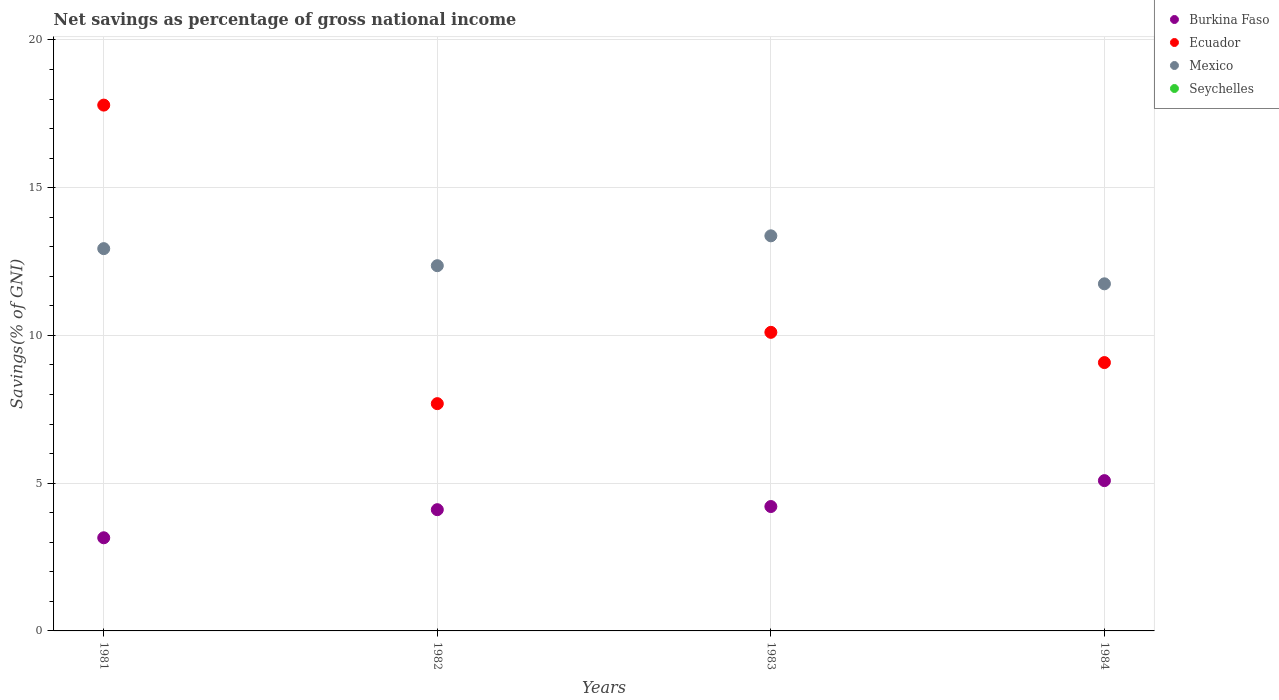What is the total savings in Mexico in 1983?
Provide a succinct answer. 13.37. Across all years, what is the maximum total savings in Mexico?
Provide a succinct answer. 13.37. Across all years, what is the minimum total savings in Ecuador?
Make the answer very short. 7.69. What is the total total savings in Seychelles in the graph?
Provide a succinct answer. 0. What is the difference between the total savings in Mexico in 1983 and that in 1984?
Make the answer very short. 1.62. What is the difference between the total savings in Mexico in 1981 and the total savings in Burkina Faso in 1982?
Your answer should be compact. 8.83. In the year 1981, what is the difference between the total savings in Ecuador and total savings in Burkina Faso?
Your answer should be compact. 14.64. In how many years, is the total savings in Mexico greater than 3 %?
Ensure brevity in your answer.  4. What is the ratio of the total savings in Burkina Faso in 1981 to that in 1983?
Provide a succinct answer. 0.75. What is the difference between the highest and the second highest total savings in Burkina Faso?
Provide a short and direct response. 0.88. What is the difference between the highest and the lowest total savings in Ecuador?
Ensure brevity in your answer.  10.1. Does the total savings in Mexico monotonically increase over the years?
Your response must be concise. No. Is the total savings in Burkina Faso strictly greater than the total savings in Ecuador over the years?
Give a very brief answer. No. Is the total savings in Ecuador strictly less than the total savings in Seychelles over the years?
Offer a terse response. No. How many dotlines are there?
Give a very brief answer. 3. How many years are there in the graph?
Provide a succinct answer. 4. What is the difference between two consecutive major ticks on the Y-axis?
Provide a succinct answer. 5. Are the values on the major ticks of Y-axis written in scientific E-notation?
Your answer should be compact. No. Does the graph contain any zero values?
Ensure brevity in your answer.  Yes. Does the graph contain grids?
Offer a very short reply. Yes. Where does the legend appear in the graph?
Keep it short and to the point. Top right. How many legend labels are there?
Ensure brevity in your answer.  4. How are the legend labels stacked?
Provide a succinct answer. Vertical. What is the title of the graph?
Keep it short and to the point. Net savings as percentage of gross national income. Does "Algeria" appear as one of the legend labels in the graph?
Offer a terse response. No. What is the label or title of the Y-axis?
Your answer should be very brief. Savings(% of GNI). What is the Savings(% of GNI) in Burkina Faso in 1981?
Your response must be concise. 3.15. What is the Savings(% of GNI) of Ecuador in 1981?
Offer a very short reply. 17.79. What is the Savings(% of GNI) in Mexico in 1981?
Your answer should be compact. 12.94. What is the Savings(% of GNI) in Seychelles in 1981?
Your response must be concise. 0. What is the Savings(% of GNI) in Burkina Faso in 1982?
Keep it short and to the point. 4.1. What is the Savings(% of GNI) in Ecuador in 1982?
Give a very brief answer. 7.69. What is the Savings(% of GNI) of Mexico in 1982?
Make the answer very short. 12.36. What is the Savings(% of GNI) of Burkina Faso in 1983?
Provide a short and direct response. 4.21. What is the Savings(% of GNI) in Ecuador in 1983?
Keep it short and to the point. 10.1. What is the Savings(% of GNI) in Mexico in 1983?
Give a very brief answer. 13.37. What is the Savings(% of GNI) in Burkina Faso in 1984?
Your answer should be compact. 5.09. What is the Savings(% of GNI) of Ecuador in 1984?
Your answer should be compact. 9.08. What is the Savings(% of GNI) in Mexico in 1984?
Ensure brevity in your answer.  11.75. What is the Savings(% of GNI) in Seychelles in 1984?
Ensure brevity in your answer.  0. Across all years, what is the maximum Savings(% of GNI) of Burkina Faso?
Provide a short and direct response. 5.09. Across all years, what is the maximum Savings(% of GNI) of Ecuador?
Make the answer very short. 17.79. Across all years, what is the maximum Savings(% of GNI) in Mexico?
Offer a terse response. 13.37. Across all years, what is the minimum Savings(% of GNI) of Burkina Faso?
Provide a short and direct response. 3.15. Across all years, what is the minimum Savings(% of GNI) of Ecuador?
Your answer should be compact. 7.69. Across all years, what is the minimum Savings(% of GNI) of Mexico?
Your answer should be compact. 11.75. What is the total Savings(% of GNI) of Burkina Faso in the graph?
Your response must be concise. 16.55. What is the total Savings(% of GNI) in Ecuador in the graph?
Give a very brief answer. 44.67. What is the total Savings(% of GNI) in Mexico in the graph?
Offer a very short reply. 50.41. What is the total Savings(% of GNI) in Seychelles in the graph?
Give a very brief answer. 0. What is the difference between the Savings(% of GNI) of Burkina Faso in 1981 and that in 1982?
Keep it short and to the point. -0.95. What is the difference between the Savings(% of GNI) of Ecuador in 1981 and that in 1982?
Your answer should be compact. 10.1. What is the difference between the Savings(% of GNI) in Mexico in 1981 and that in 1982?
Provide a short and direct response. 0.58. What is the difference between the Savings(% of GNI) of Burkina Faso in 1981 and that in 1983?
Offer a terse response. -1.06. What is the difference between the Savings(% of GNI) in Ecuador in 1981 and that in 1983?
Provide a succinct answer. 7.69. What is the difference between the Savings(% of GNI) of Mexico in 1981 and that in 1983?
Provide a succinct answer. -0.43. What is the difference between the Savings(% of GNI) of Burkina Faso in 1981 and that in 1984?
Your answer should be very brief. -1.93. What is the difference between the Savings(% of GNI) of Ecuador in 1981 and that in 1984?
Give a very brief answer. 8.71. What is the difference between the Savings(% of GNI) of Mexico in 1981 and that in 1984?
Give a very brief answer. 1.19. What is the difference between the Savings(% of GNI) in Burkina Faso in 1982 and that in 1983?
Make the answer very short. -0.11. What is the difference between the Savings(% of GNI) of Ecuador in 1982 and that in 1983?
Keep it short and to the point. -2.41. What is the difference between the Savings(% of GNI) in Mexico in 1982 and that in 1983?
Give a very brief answer. -1.01. What is the difference between the Savings(% of GNI) in Burkina Faso in 1982 and that in 1984?
Provide a succinct answer. -0.98. What is the difference between the Savings(% of GNI) of Ecuador in 1982 and that in 1984?
Give a very brief answer. -1.39. What is the difference between the Savings(% of GNI) of Mexico in 1982 and that in 1984?
Give a very brief answer. 0.61. What is the difference between the Savings(% of GNI) of Burkina Faso in 1983 and that in 1984?
Provide a succinct answer. -0.88. What is the difference between the Savings(% of GNI) in Ecuador in 1983 and that in 1984?
Your response must be concise. 1.02. What is the difference between the Savings(% of GNI) of Mexico in 1983 and that in 1984?
Offer a terse response. 1.62. What is the difference between the Savings(% of GNI) in Burkina Faso in 1981 and the Savings(% of GNI) in Ecuador in 1982?
Your response must be concise. -4.54. What is the difference between the Savings(% of GNI) of Burkina Faso in 1981 and the Savings(% of GNI) of Mexico in 1982?
Your answer should be very brief. -9.21. What is the difference between the Savings(% of GNI) of Ecuador in 1981 and the Savings(% of GNI) of Mexico in 1982?
Keep it short and to the point. 5.43. What is the difference between the Savings(% of GNI) of Burkina Faso in 1981 and the Savings(% of GNI) of Ecuador in 1983?
Provide a short and direct response. -6.95. What is the difference between the Savings(% of GNI) of Burkina Faso in 1981 and the Savings(% of GNI) of Mexico in 1983?
Make the answer very short. -10.22. What is the difference between the Savings(% of GNI) in Ecuador in 1981 and the Savings(% of GNI) in Mexico in 1983?
Provide a succinct answer. 4.42. What is the difference between the Savings(% of GNI) in Burkina Faso in 1981 and the Savings(% of GNI) in Ecuador in 1984?
Your answer should be compact. -5.93. What is the difference between the Savings(% of GNI) of Burkina Faso in 1981 and the Savings(% of GNI) of Mexico in 1984?
Give a very brief answer. -8.59. What is the difference between the Savings(% of GNI) of Ecuador in 1981 and the Savings(% of GNI) of Mexico in 1984?
Your answer should be very brief. 6.05. What is the difference between the Savings(% of GNI) of Burkina Faso in 1982 and the Savings(% of GNI) of Ecuador in 1983?
Provide a short and direct response. -6. What is the difference between the Savings(% of GNI) of Burkina Faso in 1982 and the Savings(% of GNI) of Mexico in 1983?
Provide a succinct answer. -9.27. What is the difference between the Savings(% of GNI) of Ecuador in 1982 and the Savings(% of GNI) of Mexico in 1983?
Offer a very short reply. -5.68. What is the difference between the Savings(% of GNI) of Burkina Faso in 1982 and the Savings(% of GNI) of Ecuador in 1984?
Keep it short and to the point. -4.98. What is the difference between the Savings(% of GNI) in Burkina Faso in 1982 and the Savings(% of GNI) in Mexico in 1984?
Give a very brief answer. -7.64. What is the difference between the Savings(% of GNI) in Ecuador in 1982 and the Savings(% of GNI) in Mexico in 1984?
Ensure brevity in your answer.  -4.06. What is the difference between the Savings(% of GNI) of Burkina Faso in 1983 and the Savings(% of GNI) of Ecuador in 1984?
Keep it short and to the point. -4.87. What is the difference between the Savings(% of GNI) in Burkina Faso in 1983 and the Savings(% of GNI) in Mexico in 1984?
Your response must be concise. -7.54. What is the difference between the Savings(% of GNI) in Ecuador in 1983 and the Savings(% of GNI) in Mexico in 1984?
Give a very brief answer. -1.64. What is the average Savings(% of GNI) in Burkina Faso per year?
Your answer should be very brief. 4.14. What is the average Savings(% of GNI) in Ecuador per year?
Offer a terse response. 11.17. What is the average Savings(% of GNI) in Mexico per year?
Give a very brief answer. 12.6. In the year 1981, what is the difference between the Savings(% of GNI) of Burkina Faso and Savings(% of GNI) of Ecuador?
Provide a short and direct response. -14.64. In the year 1981, what is the difference between the Savings(% of GNI) in Burkina Faso and Savings(% of GNI) in Mexico?
Your response must be concise. -9.78. In the year 1981, what is the difference between the Savings(% of GNI) of Ecuador and Savings(% of GNI) of Mexico?
Ensure brevity in your answer.  4.86. In the year 1982, what is the difference between the Savings(% of GNI) of Burkina Faso and Savings(% of GNI) of Ecuador?
Ensure brevity in your answer.  -3.59. In the year 1982, what is the difference between the Savings(% of GNI) of Burkina Faso and Savings(% of GNI) of Mexico?
Provide a succinct answer. -8.26. In the year 1982, what is the difference between the Savings(% of GNI) of Ecuador and Savings(% of GNI) of Mexico?
Make the answer very short. -4.67. In the year 1983, what is the difference between the Savings(% of GNI) in Burkina Faso and Savings(% of GNI) in Ecuador?
Ensure brevity in your answer.  -5.89. In the year 1983, what is the difference between the Savings(% of GNI) of Burkina Faso and Savings(% of GNI) of Mexico?
Provide a short and direct response. -9.16. In the year 1983, what is the difference between the Savings(% of GNI) of Ecuador and Savings(% of GNI) of Mexico?
Your answer should be very brief. -3.27. In the year 1984, what is the difference between the Savings(% of GNI) in Burkina Faso and Savings(% of GNI) in Ecuador?
Ensure brevity in your answer.  -4. In the year 1984, what is the difference between the Savings(% of GNI) of Burkina Faso and Savings(% of GNI) of Mexico?
Your response must be concise. -6.66. In the year 1984, what is the difference between the Savings(% of GNI) of Ecuador and Savings(% of GNI) of Mexico?
Provide a short and direct response. -2.67. What is the ratio of the Savings(% of GNI) in Burkina Faso in 1981 to that in 1982?
Provide a succinct answer. 0.77. What is the ratio of the Savings(% of GNI) of Ecuador in 1981 to that in 1982?
Offer a terse response. 2.31. What is the ratio of the Savings(% of GNI) of Mexico in 1981 to that in 1982?
Ensure brevity in your answer.  1.05. What is the ratio of the Savings(% of GNI) in Burkina Faso in 1981 to that in 1983?
Keep it short and to the point. 0.75. What is the ratio of the Savings(% of GNI) in Ecuador in 1981 to that in 1983?
Make the answer very short. 1.76. What is the ratio of the Savings(% of GNI) of Mexico in 1981 to that in 1983?
Your answer should be compact. 0.97. What is the ratio of the Savings(% of GNI) of Burkina Faso in 1981 to that in 1984?
Your answer should be very brief. 0.62. What is the ratio of the Savings(% of GNI) in Ecuador in 1981 to that in 1984?
Ensure brevity in your answer.  1.96. What is the ratio of the Savings(% of GNI) of Mexico in 1981 to that in 1984?
Your response must be concise. 1.1. What is the ratio of the Savings(% of GNI) in Burkina Faso in 1982 to that in 1983?
Provide a short and direct response. 0.97. What is the ratio of the Savings(% of GNI) of Ecuador in 1982 to that in 1983?
Keep it short and to the point. 0.76. What is the ratio of the Savings(% of GNI) in Mexico in 1982 to that in 1983?
Offer a terse response. 0.92. What is the ratio of the Savings(% of GNI) of Burkina Faso in 1982 to that in 1984?
Provide a short and direct response. 0.81. What is the ratio of the Savings(% of GNI) in Ecuador in 1982 to that in 1984?
Ensure brevity in your answer.  0.85. What is the ratio of the Savings(% of GNI) in Mexico in 1982 to that in 1984?
Offer a very short reply. 1.05. What is the ratio of the Savings(% of GNI) of Burkina Faso in 1983 to that in 1984?
Your answer should be compact. 0.83. What is the ratio of the Savings(% of GNI) of Ecuador in 1983 to that in 1984?
Offer a very short reply. 1.11. What is the ratio of the Savings(% of GNI) in Mexico in 1983 to that in 1984?
Offer a very short reply. 1.14. What is the difference between the highest and the second highest Savings(% of GNI) in Burkina Faso?
Your answer should be very brief. 0.88. What is the difference between the highest and the second highest Savings(% of GNI) in Ecuador?
Your response must be concise. 7.69. What is the difference between the highest and the second highest Savings(% of GNI) of Mexico?
Give a very brief answer. 0.43. What is the difference between the highest and the lowest Savings(% of GNI) in Burkina Faso?
Give a very brief answer. 1.93. What is the difference between the highest and the lowest Savings(% of GNI) in Ecuador?
Keep it short and to the point. 10.1. What is the difference between the highest and the lowest Savings(% of GNI) of Mexico?
Offer a terse response. 1.62. 